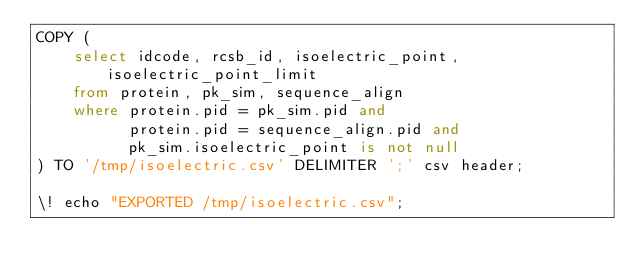Convert code to text. <code><loc_0><loc_0><loc_500><loc_500><_SQL_>COPY (
    select idcode, rcsb_id, isoelectric_point, isoelectric_point_limit
    from protein, pk_sim, sequence_align
    where protein.pid = pk_sim.pid and 
          protein.pid = sequence_align.pid and
          pk_sim.isoelectric_point is not null
) TO '/tmp/isoelectric.csv' DELIMITER ';' csv header;

\! echo "EXPORTED /tmp/isoelectric.csv";</code> 